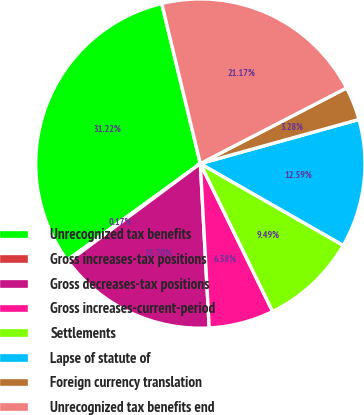Convert chart to OTSL. <chart><loc_0><loc_0><loc_500><loc_500><pie_chart><fcel>Unrecognized tax benefits<fcel>Gross increases-tax positions<fcel>Gross decreases-tax positions<fcel>Gross increases-current-period<fcel>Settlements<fcel>Lapse of statute of<fcel>Foreign currency translation<fcel>Unrecognized tax benefits end<nl><fcel>31.22%<fcel>0.17%<fcel>15.7%<fcel>6.38%<fcel>9.49%<fcel>12.59%<fcel>3.28%<fcel>21.17%<nl></chart> 